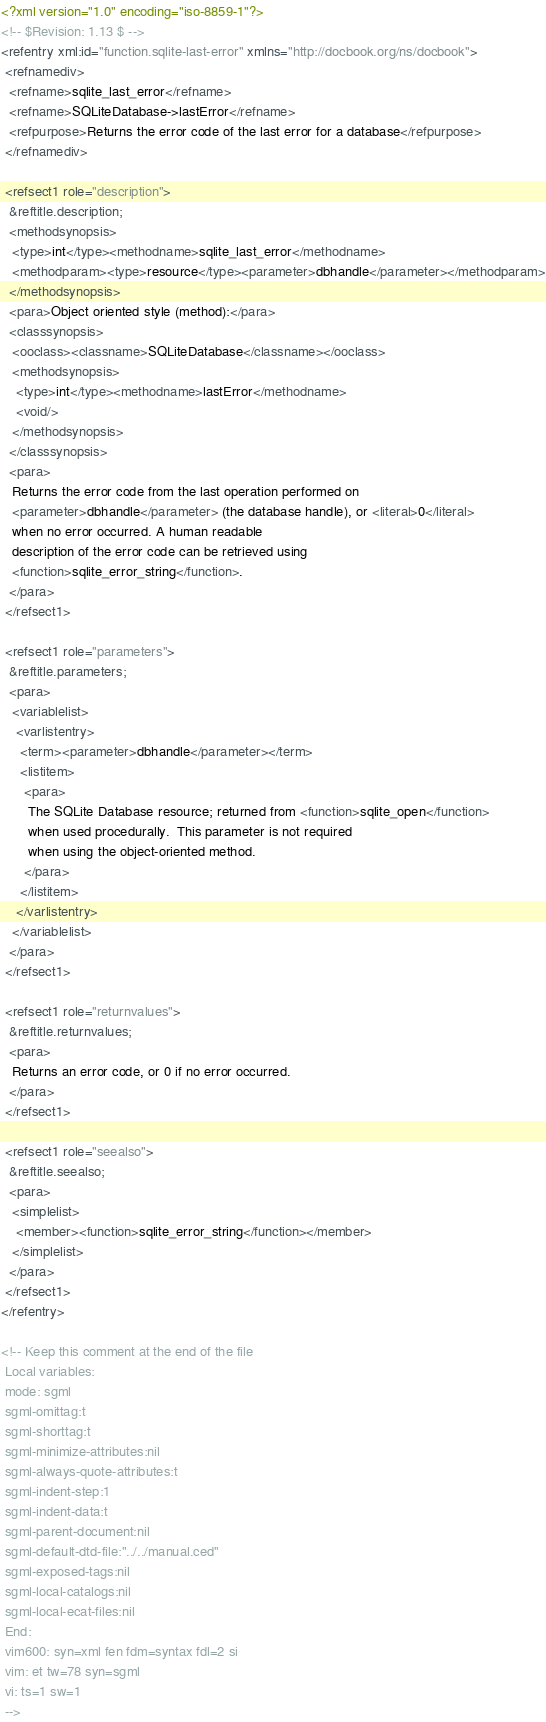<code> <loc_0><loc_0><loc_500><loc_500><_XML_><?xml version="1.0" encoding="iso-8859-1"?>
<!-- $Revision: 1.13 $ -->
<refentry xml:id="function.sqlite-last-error" xmlns="http://docbook.org/ns/docbook">
 <refnamediv>
  <refname>sqlite_last_error</refname>
  <refname>SQLiteDatabase->lastError</refname>
  <refpurpose>Returns the error code of the last error for a database</refpurpose>
 </refnamediv>

 <refsect1 role="description">
  &reftitle.description;
  <methodsynopsis>
   <type>int</type><methodname>sqlite_last_error</methodname>
   <methodparam><type>resource</type><parameter>dbhandle</parameter></methodparam>
  </methodsynopsis>
  <para>Object oriented style (method):</para>
  <classsynopsis>
   <ooclass><classname>SQLiteDatabase</classname></ooclass>
   <methodsynopsis>
    <type>int</type><methodname>lastError</methodname>
    <void/>
   </methodsynopsis>
  </classsynopsis>
  <para>
   Returns the error code from the last operation performed on
   <parameter>dbhandle</parameter> (the database handle), or <literal>0</literal>
   when no error occurred. A human readable
   description of the error code can be retrieved using
   <function>sqlite_error_string</function>.
  </para>
 </refsect1>

 <refsect1 role="parameters">
  &reftitle.parameters;
  <para>
   <variablelist>
    <varlistentry>
     <term><parameter>dbhandle</parameter></term>
     <listitem>
      <para>
       The SQLite Database resource; returned from <function>sqlite_open</function>
       when used procedurally.  This parameter is not required
       when using the object-oriented method.
      </para>
     </listitem>
    </varlistentry>
   </variablelist>
  </para>
 </refsect1>

 <refsect1 role="returnvalues">
  &reftitle.returnvalues;
  <para>
   Returns an error code, or 0 if no error occurred.
  </para>
 </refsect1>

 <refsect1 role="seealso">
  &reftitle.seealso;
  <para>
   <simplelist>
    <member><function>sqlite_error_string</function></member>
   </simplelist>
  </para>
 </refsect1>
</refentry>

<!-- Keep this comment at the end of the file
 Local variables:
 mode: sgml
 sgml-omittag:t
 sgml-shorttag:t
 sgml-minimize-attributes:nil
 sgml-always-quote-attributes:t
 sgml-indent-step:1
 sgml-indent-data:t
 sgml-parent-document:nil
 sgml-default-dtd-file:"../../manual.ced"
 sgml-exposed-tags:nil
 sgml-local-catalogs:nil
 sgml-local-ecat-files:nil
 End:
 vim600: syn=xml fen fdm=syntax fdl=2 si
 vim: et tw=78 syn=sgml
 vi: ts=1 sw=1
 -->
</code> 